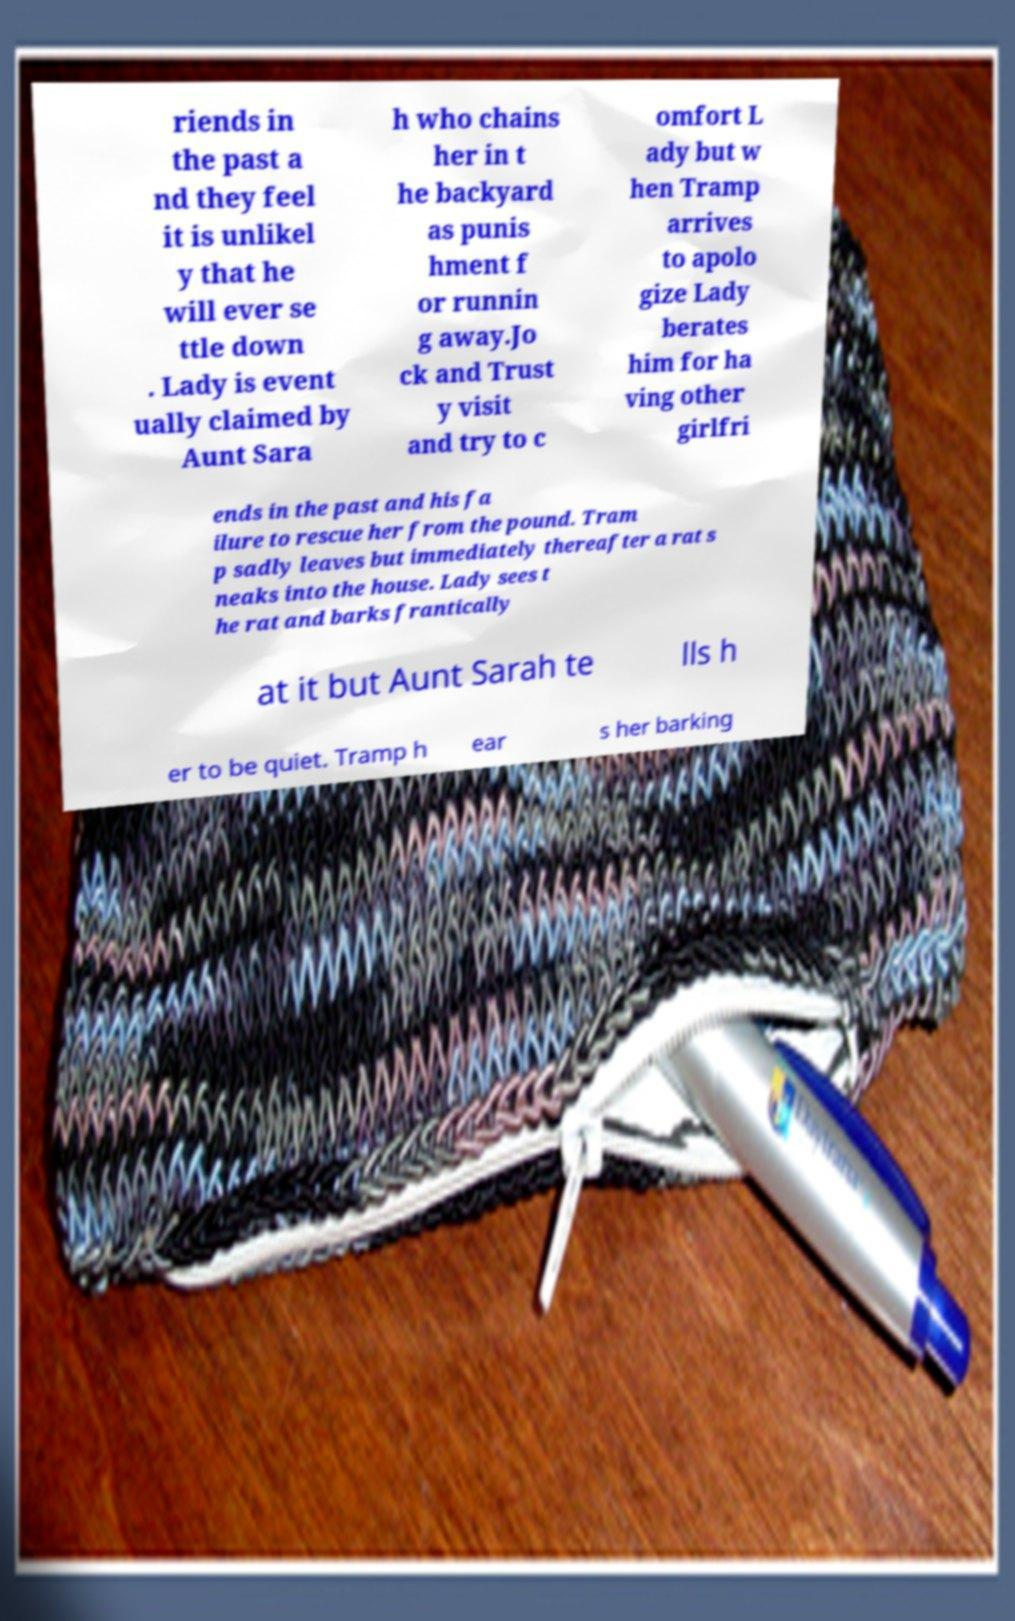For documentation purposes, I need the text within this image transcribed. Could you provide that? riends in the past a nd they feel it is unlikel y that he will ever se ttle down . Lady is event ually claimed by Aunt Sara h who chains her in t he backyard as punis hment f or runnin g away.Jo ck and Trust y visit and try to c omfort L ady but w hen Tramp arrives to apolo gize Lady berates him for ha ving other girlfri ends in the past and his fa ilure to rescue her from the pound. Tram p sadly leaves but immediately thereafter a rat s neaks into the house. Lady sees t he rat and barks frantically at it but Aunt Sarah te lls h er to be quiet. Tramp h ear s her barking 